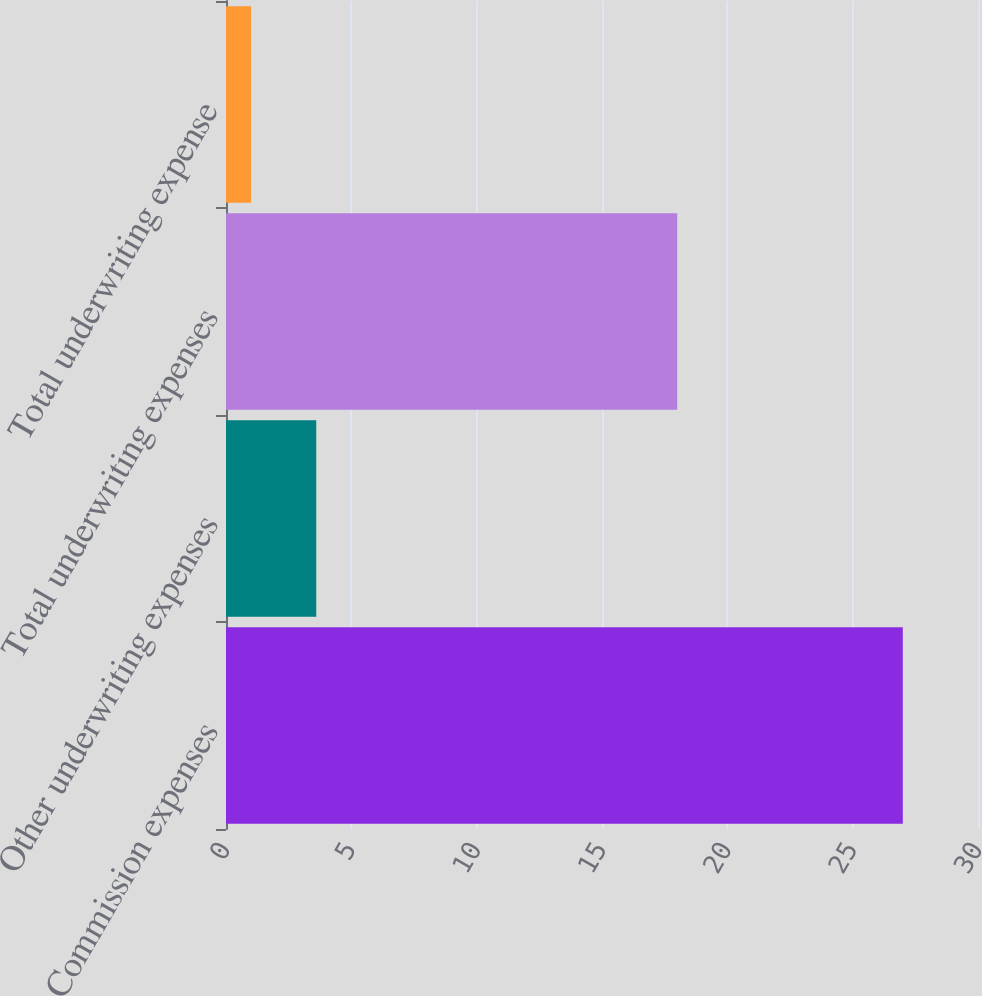<chart> <loc_0><loc_0><loc_500><loc_500><bar_chart><fcel>Commission expenses<fcel>Other underwriting expenses<fcel>Total underwriting expenses<fcel>Total underwriting expense<nl><fcel>27<fcel>3.6<fcel>18<fcel>1<nl></chart> 